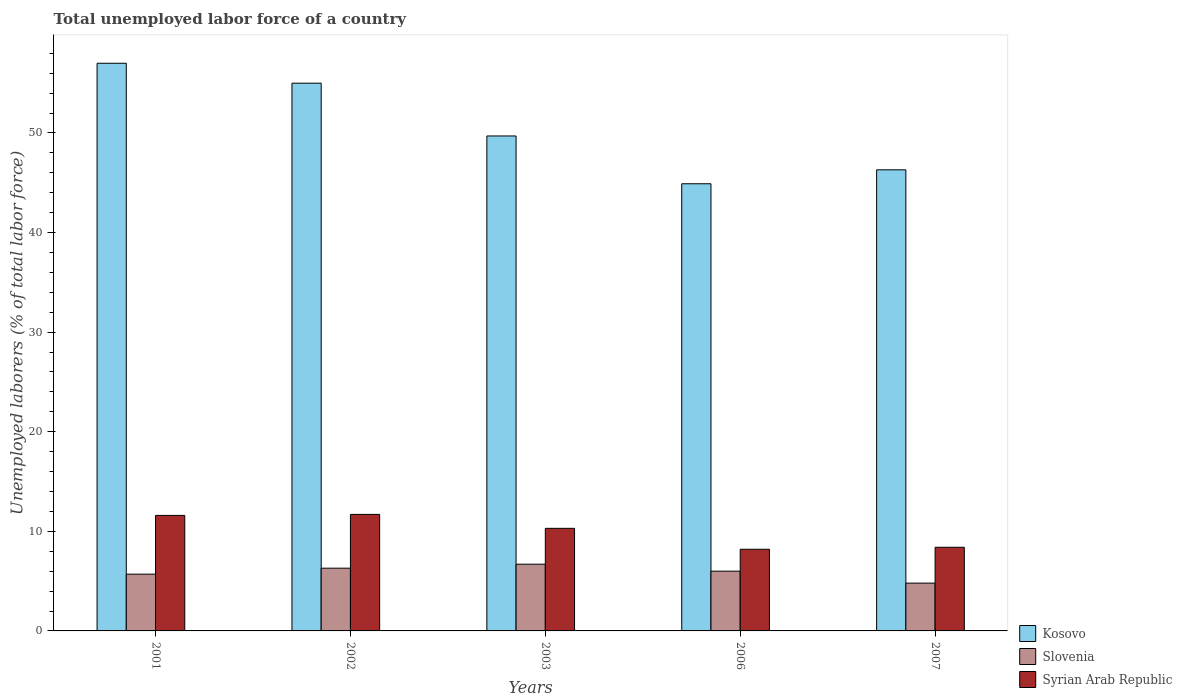How many groups of bars are there?
Your answer should be very brief. 5. Are the number of bars on each tick of the X-axis equal?
Give a very brief answer. Yes. How many bars are there on the 3rd tick from the left?
Your response must be concise. 3. How many bars are there on the 2nd tick from the right?
Make the answer very short. 3. What is the label of the 2nd group of bars from the left?
Make the answer very short. 2002. In how many cases, is the number of bars for a given year not equal to the number of legend labels?
Give a very brief answer. 0. Across all years, what is the maximum total unemployed labor force in Syrian Arab Republic?
Give a very brief answer. 11.7. Across all years, what is the minimum total unemployed labor force in Slovenia?
Give a very brief answer. 4.8. In which year was the total unemployed labor force in Kosovo minimum?
Provide a short and direct response. 2006. What is the total total unemployed labor force in Slovenia in the graph?
Ensure brevity in your answer.  29.5. What is the difference between the total unemployed labor force in Syrian Arab Republic in 2001 and that in 2002?
Make the answer very short. -0.1. What is the difference between the total unemployed labor force in Kosovo in 2007 and the total unemployed labor force in Syrian Arab Republic in 2002?
Give a very brief answer. 34.6. In the year 2007, what is the difference between the total unemployed labor force in Kosovo and total unemployed labor force in Slovenia?
Offer a very short reply. 41.5. What is the ratio of the total unemployed labor force in Kosovo in 2003 to that in 2006?
Offer a very short reply. 1.11. What is the difference between the highest and the second highest total unemployed labor force in Slovenia?
Provide a short and direct response. 0.4. What is the difference between the highest and the lowest total unemployed labor force in Slovenia?
Your answer should be compact. 1.9. In how many years, is the total unemployed labor force in Kosovo greater than the average total unemployed labor force in Kosovo taken over all years?
Offer a very short reply. 2. What does the 3rd bar from the left in 2007 represents?
Give a very brief answer. Syrian Arab Republic. What does the 2nd bar from the right in 2006 represents?
Give a very brief answer. Slovenia. Is it the case that in every year, the sum of the total unemployed labor force in Slovenia and total unemployed labor force in Syrian Arab Republic is greater than the total unemployed labor force in Kosovo?
Give a very brief answer. No. Are all the bars in the graph horizontal?
Your response must be concise. No. How many years are there in the graph?
Provide a short and direct response. 5. Does the graph contain grids?
Provide a short and direct response. No. Where does the legend appear in the graph?
Your answer should be compact. Bottom right. How are the legend labels stacked?
Your answer should be compact. Vertical. What is the title of the graph?
Your answer should be compact. Total unemployed labor force of a country. Does "Cabo Verde" appear as one of the legend labels in the graph?
Your answer should be compact. No. What is the label or title of the X-axis?
Your response must be concise. Years. What is the label or title of the Y-axis?
Ensure brevity in your answer.  Unemployed laborers (% of total labor force). What is the Unemployed laborers (% of total labor force) in Slovenia in 2001?
Your answer should be compact. 5.7. What is the Unemployed laborers (% of total labor force) of Syrian Arab Republic in 2001?
Ensure brevity in your answer.  11.6. What is the Unemployed laborers (% of total labor force) in Slovenia in 2002?
Offer a terse response. 6.3. What is the Unemployed laborers (% of total labor force) in Syrian Arab Republic in 2002?
Your response must be concise. 11.7. What is the Unemployed laborers (% of total labor force) in Kosovo in 2003?
Your answer should be very brief. 49.7. What is the Unemployed laborers (% of total labor force) of Slovenia in 2003?
Give a very brief answer. 6.7. What is the Unemployed laborers (% of total labor force) in Syrian Arab Republic in 2003?
Provide a short and direct response. 10.3. What is the Unemployed laborers (% of total labor force) of Kosovo in 2006?
Provide a succinct answer. 44.9. What is the Unemployed laborers (% of total labor force) of Syrian Arab Republic in 2006?
Offer a terse response. 8.2. What is the Unemployed laborers (% of total labor force) in Kosovo in 2007?
Your answer should be compact. 46.3. What is the Unemployed laborers (% of total labor force) in Slovenia in 2007?
Provide a short and direct response. 4.8. What is the Unemployed laborers (% of total labor force) of Syrian Arab Republic in 2007?
Offer a terse response. 8.4. Across all years, what is the maximum Unemployed laborers (% of total labor force) in Kosovo?
Make the answer very short. 57. Across all years, what is the maximum Unemployed laborers (% of total labor force) of Slovenia?
Provide a succinct answer. 6.7. Across all years, what is the maximum Unemployed laborers (% of total labor force) of Syrian Arab Republic?
Give a very brief answer. 11.7. Across all years, what is the minimum Unemployed laborers (% of total labor force) in Kosovo?
Your response must be concise. 44.9. Across all years, what is the minimum Unemployed laborers (% of total labor force) in Slovenia?
Your response must be concise. 4.8. Across all years, what is the minimum Unemployed laborers (% of total labor force) of Syrian Arab Republic?
Ensure brevity in your answer.  8.2. What is the total Unemployed laborers (% of total labor force) in Kosovo in the graph?
Make the answer very short. 252.9. What is the total Unemployed laborers (% of total labor force) in Slovenia in the graph?
Your answer should be very brief. 29.5. What is the total Unemployed laborers (% of total labor force) in Syrian Arab Republic in the graph?
Offer a very short reply. 50.2. What is the difference between the Unemployed laborers (% of total labor force) in Slovenia in 2001 and that in 2002?
Make the answer very short. -0.6. What is the difference between the Unemployed laborers (% of total labor force) in Syrian Arab Republic in 2001 and that in 2003?
Your answer should be compact. 1.3. What is the difference between the Unemployed laborers (% of total labor force) in Kosovo in 2001 and that in 2006?
Offer a very short reply. 12.1. What is the difference between the Unemployed laborers (% of total labor force) in Slovenia in 2001 and that in 2007?
Offer a terse response. 0.9. What is the difference between the Unemployed laborers (% of total labor force) in Syrian Arab Republic in 2001 and that in 2007?
Make the answer very short. 3.2. What is the difference between the Unemployed laborers (% of total labor force) of Slovenia in 2002 and that in 2003?
Offer a terse response. -0.4. What is the difference between the Unemployed laborers (% of total labor force) in Syrian Arab Republic in 2002 and that in 2003?
Ensure brevity in your answer.  1.4. What is the difference between the Unemployed laborers (% of total labor force) of Kosovo in 2002 and that in 2006?
Provide a succinct answer. 10.1. What is the difference between the Unemployed laborers (% of total labor force) of Syrian Arab Republic in 2002 and that in 2006?
Provide a succinct answer. 3.5. What is the difference between the Unemployed laborers (% of total labor force) in Kosovo in 2002 and that in 2007?
Your answer should be compact. 8.7. What is the difference between the Unemployed laborers (% of total labor force) in Syrian Arab Republic in 2002 and that in 2007?
Offer a very short reply. 3.3. What is the difference between the Unemployed laborers (% of total labor force) of Kosovo in 2003 and that in 2006?
Keep it short and to the point. 4.8. What is the difference between the Unemployed laborers (% of total labor force) of Syrian Arab Republic in 2003 and that in 2006?
Provide a succinct answer. 2.1. What is the difference between the Unemployed laborers (% of total labor force) of Kosovo in 2003 and that in 2007?
Your answer should be very brief. 3.4. What is the difference between the Unemployed laborers (% of total labor force) in Syrian Arab Republic in 2003 and that in 2007?
Your response must be concise. 1.9. What is the difference between the Unemployed laborers (% of total labor force) in Kosovo in 2006 and that in 2007?
Keep it short and to the point. -1.4. What is the difference between the Unemployed laborers (% of total labor force) in Slovenia in 2006 and that in 2007?
Your answer should be compact. 1.2. What is the difference between the Unemployed laborers (% of total labor force) of Syrian Arab Republic in 2006 and that in 2007?
Your answer should be very brief. -0.2. What is the difference between the Unemployed laborers (% of total labor force) in Kosovo in 2001 and the Unemployed laborers (% of total labor force) in Slovenia in 2002?
Your answer should be compact. 50.7. What is the difference between the Unemployed laborers (% of total labor force) in Kosovo in 2001 and the Unemployed laborers (% of total labor force) in Syrian Arab Republic in 2002?
Your answer should be compact. 45.3. What is the difference between the Unemployed laborers (% of total labor force) of Slovenia in 2001 and the Unemployed laborers (% of total labor force) of Syrian Arab Republic in 2002?
Keep it short and to the point. -6. What is the difference between the Unemployed laborers (% of total labor force) of Kosovo in 2001 and the Unemployed laborers (% of total labor force) of Slovenia in 2003?
Offer a terse response. 50.3. What is the difference between the Unemployed laborers (% of total labor force) in Kosovo in 2001 and the Unemployed laborers (% of total labor force) in Syrian Arab Republic in 2003?
Offer a very short reply. 46.7. What is the difference between the Unemployed laborers (% of total labor force) in Kosovo in 2001 and the Unemployed laborers (% of total labor force) in Syrian Arab Republic in 2006?
Ensure brevity in your answer.  48.8. What is the difference between the Unemployed laborers (% of total labor force) of Slovenia in 2001 and the Unemployed laborers (% of total labor force) of Syrian Arab Republic in 2006?
Your response must be concise. -2.5. What is the difference between the Unemployed laborers (% of total labor force) of Kosovo in 2001 and the Unemployed laborers (% of total labor force) of Slovenia in 2007?
Your response must be concise. 52.2. What is the difference between the Unemployed laborers (% of total labor force) in Kosovo in 2001 and the Unemployed laborers (% of total labor force) in Syrian Arab Republic in 2007?
Ensure brevity in your answer.  48.6. What is the difference between the Unemployed laborers (% of total labor force) of Kosovo in 2002 and the Unemployed laborers (% of total labor force) of Slovenia in 2003?
Offer a terse response. 48.3. What is the difference between the Unemployed laborers (% of total labor force) of Kosovo in 2002 and the Unemployed laborers (% of total labor force) of Syrian Arab Republic in 2003?
Provide a short and direct response. 44.7. What is the difference between the Unemployed laborers (% of total labor force) in Kosovo in 2002 and the Unemployed laborers (% of total labor force) in Slovenia in 2006?
Your answer should be compact. 49. What is the difference between the Unemployed laborers (% of total labor force) of Kosovo in 2002 and the Unemployed laborers (% of total labor force) of Syrian Arab Republic in 2006?
Provide a succinct answer. 46.8. What is the difference between the Unemployed laborers (% of total labor force) of Kosovo in 2002 and the Unemployed laborers (% of total labor force) of Slovenia in 2007?
Provide a short and direct response. 50.2. What is the difference between the Unemployed laborers (% of total labor force) in Kosovo in 2002 and the Unemployed laborers (% of total labor force) in Syrian Arab Republic in 2007?
Offer a very short reply. 46.6. What is the difference between the Unemployed laborers (% of total labor force) in Kosovo in 2003 and the Unemployed laborers (% of total labor force) in Slovenia in 2006?
Offer a terse response. 43.7. What is the difference between the Unemployed laborers (% of total labor force) of Kosovo in 2003 and the Unemployed laborers (% of total labor force) of Syrian Arab Republic in 2006?
Your answer should be compact. 41.5. What is the difference between the Unemployed laborers (% of total labor force) of Slovenia in 2003 and the Unemployed laborers (% of total labor force) of Syrian Arab Republic in 2006?
Keep it short and to the point. -1.5. What is the difference between the Unemployed laborers (% of total labor force) in Kosovo in 2003 and the Unemployed laborers (% of total labor force) in Slovenia in 2007?
Offer a terse response. 44.9. What is the difference between the Unemployed laborers (% of total labor force) in Kosovo in 2003 and the Unemployed laborers (% of total labor force) in Syrian Arab Republic in 2007?
Give a very brief answer. 41.3. What is the difference between the Unemployed laborers (% of total labor force) in Kosovo in 2006 and the Unemployed laborers (% of total labor force) in Slovenia in 2007?
Your response must be concise. 40.1. What is the difference between the Unemployed laborers (% of total labor force) in Kosovo in 2006 and the Unemployed laborers (% of total labor force) in Syrian Arab Republic in 2007?
Provide a short and direct response. 36.5. What is the average Unemployed laborers (% of total labor force) of Kosovo per year?
Your answer should be compact. 50.58. What is the average Unemployed laborers (% of total labor force) in Slovenia per year?
Your response must be concise. 5.9. What is the average Unemployed laborers (% of total labor force) in Syrian Arab Republic per year?
Offer a terse response. 10.04. In the year 2001, what is the difference between the Unemployed laborers (% of total labor force) in Kosovo and Unemployed laborers (% of total labor force) in Slovenia?
Give a very brief answer. 51.3. In the year 2001, what is the difference between the Unemployed laborers (% of total labor force) of Kosovo and Unemployed laborers (% of total labor force) of Syrian Arab Republic?
Provide a short and direct response. 45.4. In the year 2002, what is the difference between the Unemployed laborers (% of total labor force) in Kosovo and Unemployed laborers (% of total labor force) in Slovenia?
Provide a succinct answer. 48.7. In the year 2002, what is the difference between the Unemployed laborers (% of total labor force) in Kosovo and Unemployed laborers (% of total labor force) in Syrian Arab Republic?
Give a very brief answer. 43.3. In the year 2002, what is the difference between the Unemployed laborers (% of total labor force) in Slovenia and Unemployed laborers (% of total labor force) in Syrian Arab Republic?
Your answer should be compact. -5.4. In the year 2003, what is the difference between the Unemployed laborers (% of total labor force) in Kosovo and Unemployed laborers (% of total labor force) in Syrian Arab Republic?
Keep it short and to the point. 39.4. In the year 2006, what is the difference between the Unemployed laborers (% of total labor force) in Kosovo and Unemployed laborers (% of total labor force) in Slovenia?
Give a very brief answer. 38.9. In the year 2006, what is the difference between the Unemployed laborers (% of total labor force) in Kosovo and Unemployed laborers (% of total labor force) in Syrian Arab Republic?
Your answer should be very brief. 36.7. In the year 2007, what is the difference between the Unemployed laborers (% of total labor force) of Kosovo and Unemployed laborers (% of total labor force) of Slovenia?
Provide a short and direct response. 41.5. In the year 2007, what is the difference between the Unemployed laborers (% of total labor force) of Kosovo and Unemployed laborers (% of total labor force) of Syrian Arab Republic?
Ensure brevity in your answer.  37.9. In the year 2007, what is the difference between the Unemployed laborers (% of total labor force) in Slovenia and Unemployed laborers (% of total labor force) in Syrian Arab Republic?
Offer a very short reply. -3.6. What is the ratio of the Unemployed laborers (% of total labor force) in Kosovo in 2001 to that in 2002?
Offer a terse response. 1.04. What is the ratio of the Unemployed laborers (% of total labor force) of Slovenia in 2001 to that in 2002?
Make the answer very short. 0.9. What is the ratio of the Unemployed laborers (% of total labor force) in Syrian Arab Republic in 2001 to that in 2002?
Your answer should be very brief. 0.99. What is the ratio of the Unemployed laborers (% of total labor force) in Kosovo in 2001 to that in 2003?
Your answer should be compact. 1.15. What is the ratio of the Unemployed laborers (% of total labor force) in Slovenia in 2001 to that in 2003?
Offer a terse response. 0.85. What is the ratio of the Unemployed laborers (% of total labor force) of Syrian Arab Republic in 2001 to that in 2003?
Ensure brevity in your answer.  1.13. What is the ratio of the Unemployed laborers (% of total labor force) of Kosovo in 2001 to that in 2006?
Provide a short and direct response. 1.27. What is the ratio of the Unemployed laborers (% of total labor force) of Slovenia in 2001 to that in 2006?
Provide a short and direct response. 0.95. What is the ratio of the Unemployed laborers (% of total labor force) in Syrian Arab Republic in 2001 to that in 2006?
Keep it short and to the point. 1.41. What is the ratio of the Unemployed laborers (% of total labor force) of Kosovo in 2001 to that in 2007?
Your answer should be very brief. 1.23. What is the ratio of the Unemployed laborers (% of total labor force) of Slovenia in 2001 to that in 2007?
Provide a succinct answer. 1.19. What is the ratio of the Unemployed laborers (% of total labor force) of Syrian Arab Republic in 2001 to that in 2007?
Provide a succinct answer. 1.38. What is the ratio of the Unemployed laborers (% of total labor force) in Kosovo in 2002 to that in 2003?
Provide a short and direct response. 1.11. What is the ratio of the Unemployed laborers (% of total labor force) in Slovenia in 2002 to that in 2003?
Give a very brief answer. 0.94. What is the ratio of the Unemployed laborers (% of total labor force) in Syrian Arab Republic in 2002 to that in 2003?
Provide a succinct answer. 1.14. What is the ratio of the Unemployed laborers (% of total labor force) in Kosovo in 2002 to that in 2006?
Ensure brevity in your answer.  1.22. What is the ratio of the Unemployed laborers (% of total labor force) in Syrian Arab Republic in 2002 to that in 2006?
Make the answer very short. 1.43. What is the ratio of the Unemployed laborers (% of total labor force) of Kosovo in 2002 to that in 2007?
Offer a very short reply. 1.19. What is the ratio of the Unemployed laborers (% of total labor force) in Slovenia in 2002 to that in 2007?
Make the answer very short. 1.31. What is the ratio of the Unemployed laborers (% of total labor force) of Syrian Arab Republic in 2002 to that in 2007?
Make the answer very short. 1.39. What is the ratio of the Unemployed laborers (% of total labor force) of Kosovo in 2003 to that in 2006?
Offer a very short reply. 1.11. What is the ratio of the Unemployed laborers (% of total labor force) in Slovenia in 2003 to that in 2006?
Your answer should be very brief. 1.12. What is the ratio of the Unemployed laborers (% of total labor force) in Syrian Arab Republic in 2003 to that in 2006?
Ensure brevity in your answer.  1.26. What is the ratio of the Unemployed laborers (% of total labor force) in Kosovo in 2003 to that in 2007?
Keep it short and to the point. 1.07. What is the ratio of the Unemployed laborers (% of total labor force) of Slovenia in 2003 to that in 2007?
Ensure brevity in your answer.  1.4. What is the ratio of the Unemployed laborers (% of total labor force) in Syrian Arab Republic in 2003 to that in 2007?
Provide a succinct answer. 1.23. What is the ratio of the Unemployed laborers (% of total labor force) of Kosovo in 2006 to that in 2007?
Give a very brief answer. 0.97. What is the ratio of the Unemployed laborers (% of total labor force) of Syrian Arab Republic in 2006 to that in 2007?
Keep it short and to the point. 0.98. What is the difference between the highest and the second highest Unemployed laborers (% of total labor force) in Syrian Arab Republic?
Ensure brevity in your answer.  0.1. What is the difference between the highest and the lowest Unemployed laborers (% of total labor force) of Kosovo?
Ensure brevity in your answer.  12.1. What is the difference between the highest and the lowest Unemployed laborers (% of total labor force) in Syrian Arab Republic?
Your answer should be very brief. 3.5. 